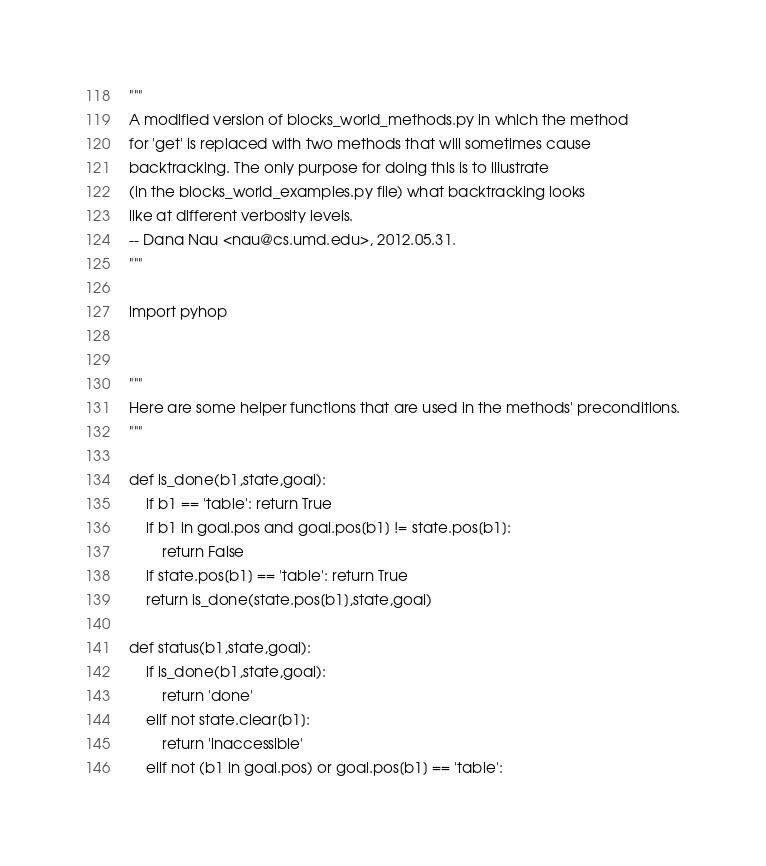Convert code to text. <code><loc_0><loc_0><loc_500><loc_500><_Python_>"""
A modified version of blocks_world_methods.py in which the method
for 'get' is replaced with two methods that will sometimes cause
backtracking. The only purpose for doing this is to illustrate
(in the blocks_world_examples.py file) what backtracking looks
like at different verbosity levels.
-- Dana Nau <nau@cs.umd.edu>, 2012.05.31.
"""

import pyhop


"""
Here are some helper functions that are used in the methods' preconditions.
"""

def is_done(b1,state,goal):
    if b1 == 'table': return True
    if b1 in goal.pos and goal.pos[b1] != state.pos[b1]:
        return False
    if state.pos[b1] == 'table': return True
    return is_done(state.pos[b1],state,goal)

def status(b1,state,goal):
    if is_done(b1,state,goal):
        return 'done'
    elif not state.clear[b1]:
        return 'inaccessible'
    elif not (b1 in goal.pos) or goal.pos[b1] == 'table':</code> 